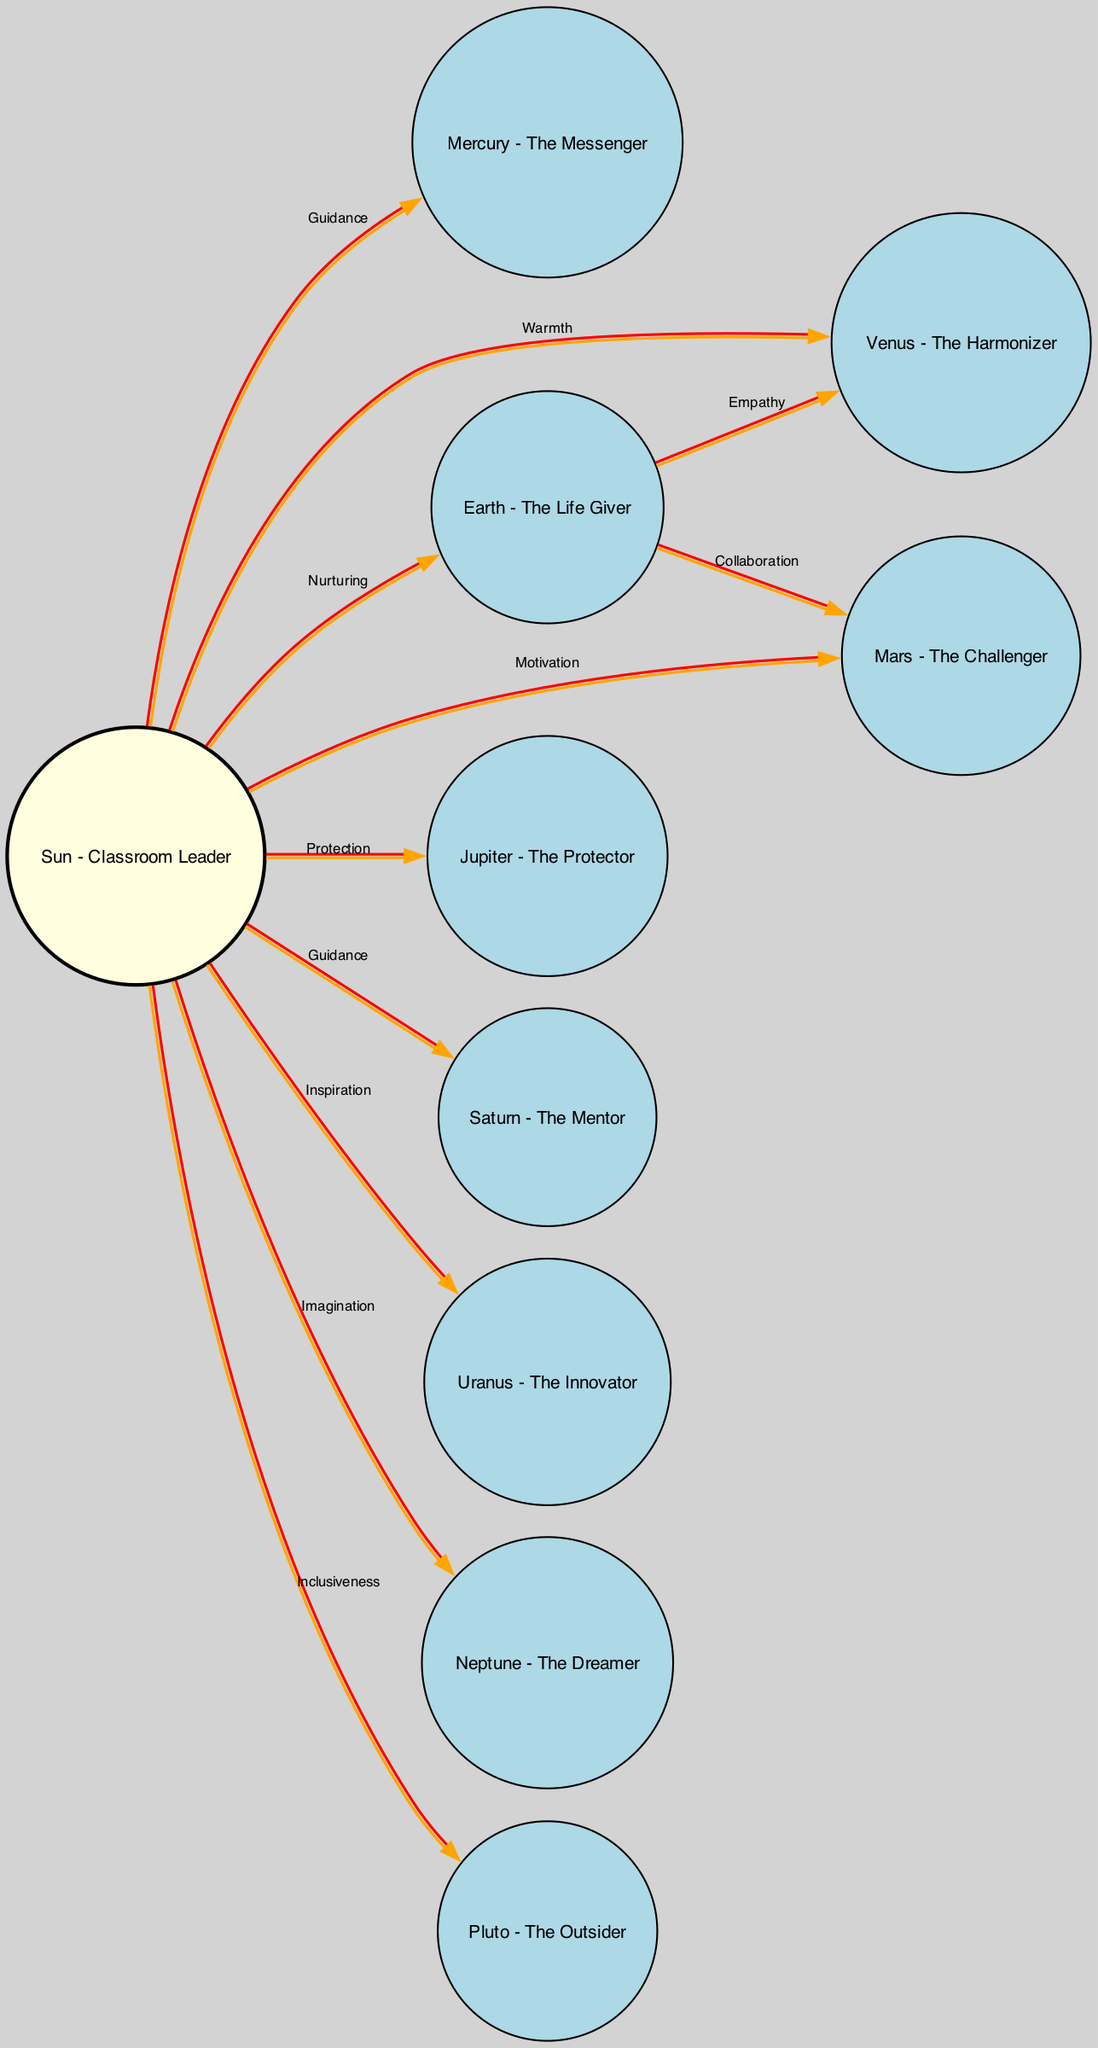What is the main role of the Sun in this diagram? The Sun is labeled as the "Classroom Leader," indicating it is central to the community and influences all other elements within the diagram.
Answer: Classroom Leader How many nodes are present in the diagram? By counting the entries in the 'nodes' list within the data, we see there are ten distinct nodes representing various community roles related to classrooms and star clusters.
Answer: 10 What two nodes does the Sun connect to with the label "Guidance"? The edges originating from the Sun labeled "Guidance" lead to both Mercury and Saturn, showing how the Sun provides guidance to these specific roles in the community.
Answer: Mercury, Saturn Which node represents collaboration in the community? The node labeled Earth has an edge directed towards Mars with the label "Collaboration," indicating that Earth fosters a collaborative spirit among the community members.
Answer: Earth Which node encourages empathy among peers? Venus is noted as "The Harmonizer" and is described specifically as fostering empathy, highlighting its role in enhancing relationships within the community.
Answer: Venus How many connections does the Sun have to other nodes? The Sun connects to nine other nodes in the diagram, reflecting its central role in nurturing and influencing the various community elements.
Answer: 9 What is the relationship between Earth and Venus in the diagram? Earth and Venus share an edge labeled "Empathy," indicating that Earth supports the promotion of empathy through Venus within the community structure.
Answer: Empathy What role does Neptune fulfill in this community? Neptune is labeled as "The Dreamer," which signifies its role in inspiring imagination and artistic expression among the community members.
Answer: The Dreamer What type of member does Pluto represent in the community? Pluto is described as "The Outsider," which suggests its role is to represent members who think differently, providing diversity to the overall community dynamic.
Answer: The Outsider 